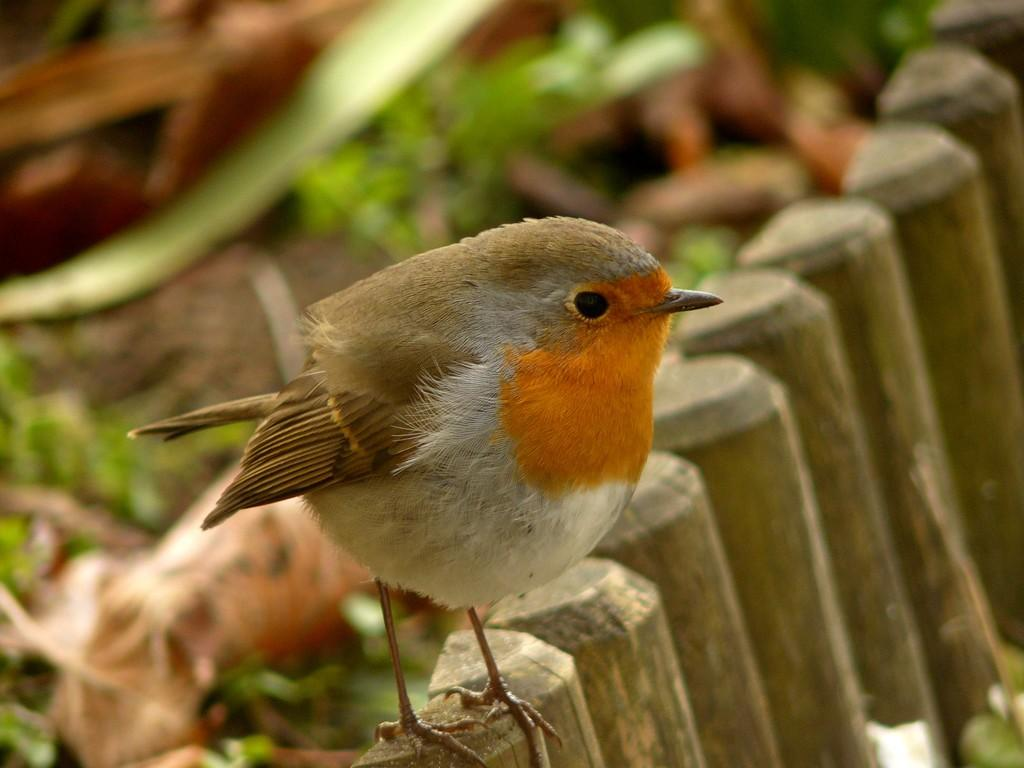What is the main subject in the foreground of the image? There is a bird in the foreground of the image. Where is the bird located? The bird is on a wooden railing. Can you describe the background of the image? The background of the image is blurred. What type of prose can be heard being read by the beggar in the image? There is no beggar or prose present in the image; it features a bird on a wooden railing with a blurred background. 